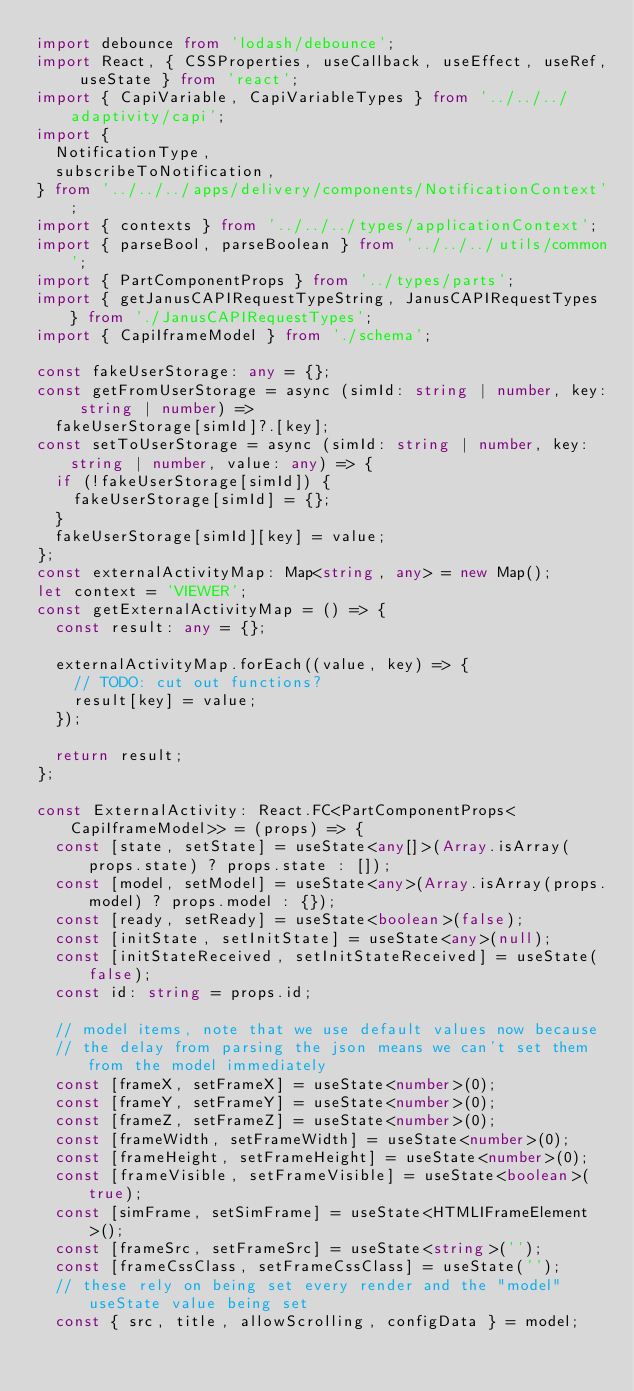Convert code to text. <code><loc_0><loc_0><loc_500><loc_500><_TypeScript_>import debounce from 'lodash/debounce';
import React, { CSSProperties, useCallback, useEffect, useRef, useState } from 'react';
import { CapiVariable, CapiVariableTypes } from '../../../adaptivity/capi';
import {
  NotificationType,
  subscribeToNotification,
} from '../../../apps/delivery/components/NotificationContext';
import { contexts } from '../../../types/applicationContext';
import { parseBool, parseBoolean } from '../../../utils/common';
import { PartComponentProps } from '../types/parts';
import { getJanusCAPIRequestTypeString, JanusCAPIRequestTypes } from './JanusCAPIRequestTypes';
import { CapiIframeModel } from './schema';

const fakeUserStorage: any = {};
const getFromUserStorage = async (simId: string | number, key: string | number) =>
  fakeUserStorage[simId]?.[key];
const setToUserStorage = async (simId: string | number, key: string | number, value: any) => {
  if (!fakeUserStorage[simId]) {
    fakeUserStorage[simId] = {};
  }
  fakeUserStorage[simId][key] = value;
};
const externalActivityMap: Map<string, any> = new Map();
let context = 'VIEWER';
const getExternalActivityMap = () => {
  const result: any = {};

  externalActivityMap.forEach((value, key) => {
    // TODO: cut out functions?
    result[key] = value;
  });

  return result;
};

const ExternalActivity: React.FC<PartComponentProps<CapiIframeModel>> = (props) => {
  const [state, setState] = useState<any[]>(Array.isArray(props.state) ? props.state : []);
  const [model, setModel] = useState<any>(Array.isArray(props.model) ? props.model : {});
  const [ready, setReady] = useState<boolean>(false);
  const [initState, setInitState] = useState<any>(null);
  const [initStateReceived, setInitStateReceived] = useState(false);
  const id: string = props.id;

  // model items, note that we use default values now because
  // the delay from parsing the json means we can't set them from the model immediately
  const [frameX, setFrameX] = useState<number>(0);
  const [frameY, setFrameY] = useState<number>(0);
  const [frameZ, setFrameZ] = useState<number>(0);
  const [frameWidth, setFrameWidth] = useState<number>(0);
  const [frameHeight, setFrameHeight] = useState<number>(0);
  const [frameVisible, setFrameVisible] = useState<boolean>(true);
  const [simFrame, setSimFrame] = useState<HTMLIFrameElement>();
  const [frameSrc, setFrameSrc] = useState<string>('');
  const [frameCssClass, setFrameCssClass] = useState('');
  // these rely on being set every render and the "model" useState value being set
  const { src, title, allowScrolling, configData } = model;
</code> 